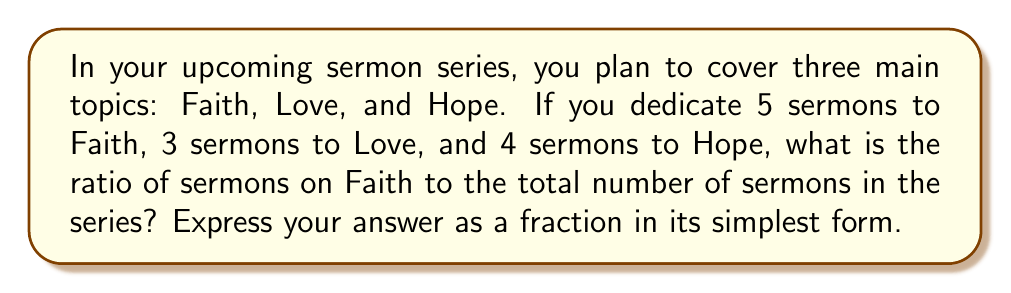Teach me how to tackle this problem. Let's approach this step-by-step:

1) First, let's calculate the total number of sermons in the series:
   Faith: 5 sermons
   Love: 3 sermons
   Hope: 4 sermons
   
   Total: $5 + 3 + 4 = 12$ sermons

2) Now, we need to form a ratio of Faith sermons to the total number of sermons:
   $$\frac{\text{Number of Faith sermons}}{\text{Total number of sermons}} = \frac{5}{12}$$

3) This fraction $\frac{5}{12}$ is already in its simplest form, as 5 and 12 have no common factors other than 1.

Therefore, the ratio of sermons on Faith to the total number of sermons is $\frac{5}{12}$.
Answer: $\frac{5}{12}$ 